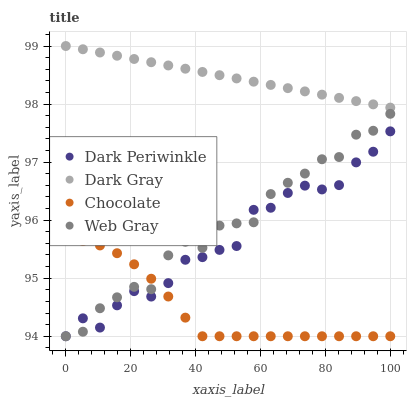Does Chocolate have the minimum area under the curve?
Answer yes or no. Yes. Does Dark Gray have the maximum area under the curve?
Answer yes or no. Yes. Does Web Gray have the minimum area under the curve?
Answer yes or no. No. Does Web Gray have the maximum area under the curve?
Answer yes or no. No. Is Dark Gray the smoothest?
Answer yes or no. Yes. Is Dark Periwinkle the roughest?
Answer yes or no. Yes. Is Web Gray the smoothest?
Answer yes or no. No. Is Web Gray the roughest?
Answer yes or no. No. Does Web Gray have the lowest value?
Answer yes or no. Yes. Does Dark Gray have the highest value?
Answer yes or no. Yes. Does Web Gray have the highest value?
Answer yes or no. No. Is Chocolate less than Dark Gray?
Answer yes or no. Yes. Is Dark Gray greater than Web Gray?
Answer yes or no. Yes. Does Dark Periwinkle intersect Web Gray?
Answer yes or no. Yes. Is Dark Periwinkle less than Web Gray?
Answer yes or no. No. Is Dark Periwinkle greater than Web Gray?
Answer yes or no. No. Does Chocolate intersect Dark Gray?
Answer yes or no. No. 